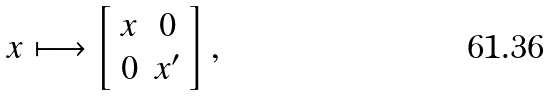Convert formula to latex. <formula><loc_0><loc_0><loc_500><loc_500>x \longmapsto \left [ \begin{array} { c c } x & 0 \\ 0 & x ^ { \prime } \end{array} \right ] ,</formula> 